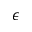<formula> <loc_0><loc_0><loc_500><loc_500>\epsilon</formula> 